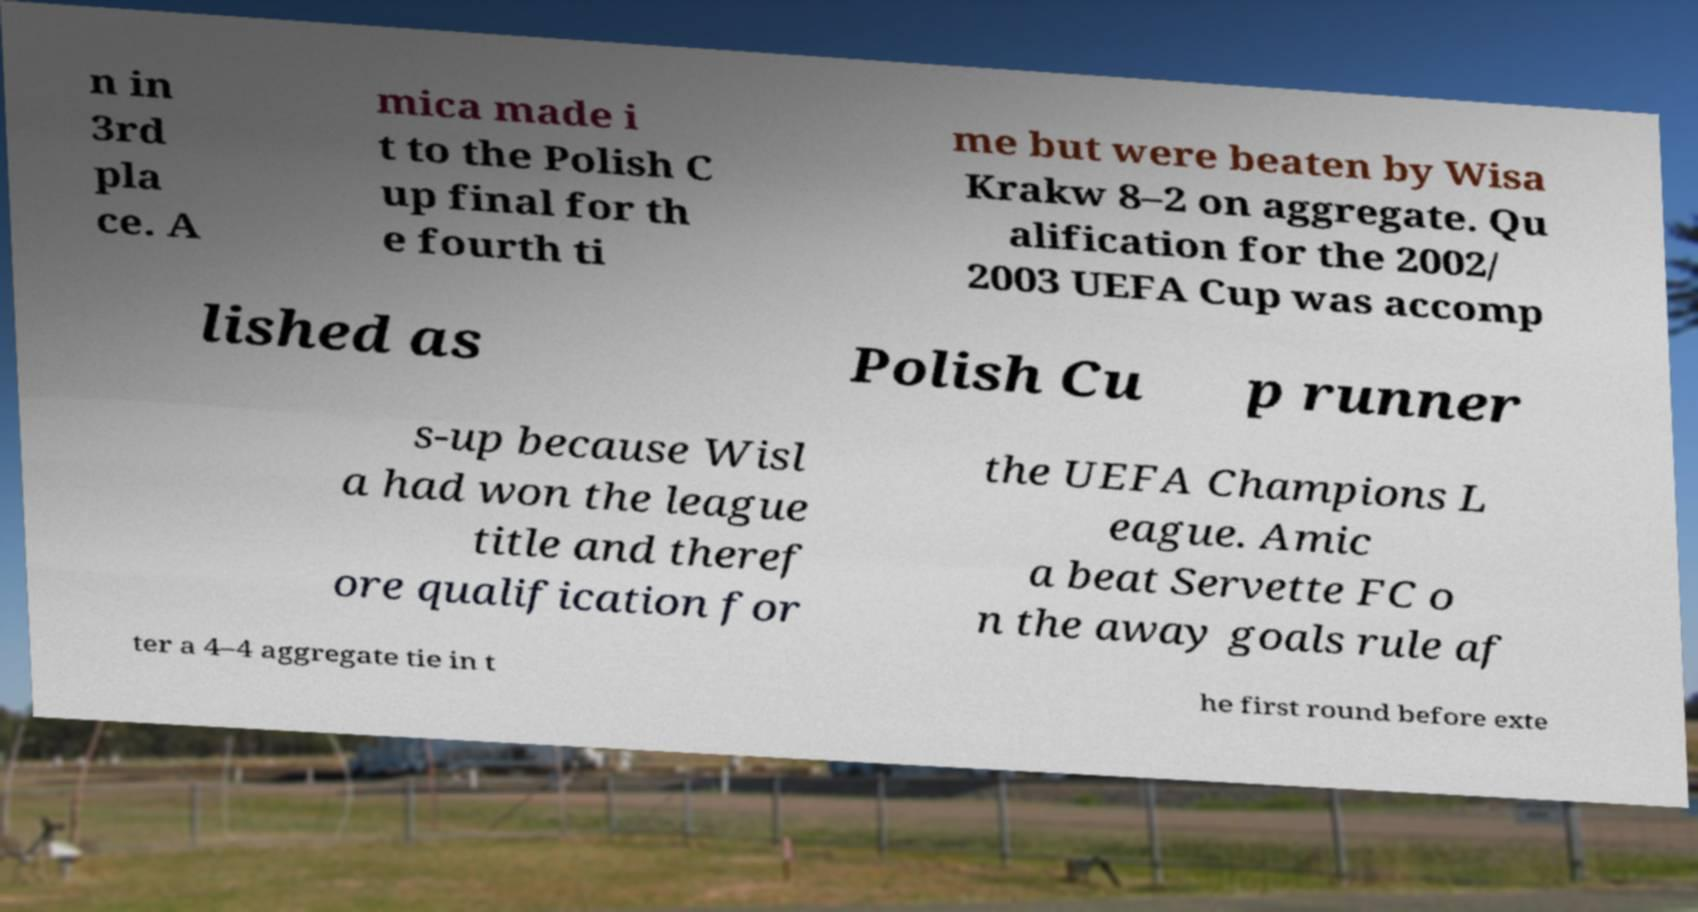Could you extract and type out the text from this image? n in 3rd pla ce. A mica made i t to the Polish C up final for th e fourth ti me but were beaten by Wisa Krakw 8–2 on aggregate. Qu alification for the 2002/ 2003 UEFA Cup was accomp lished as Polish Cu p runner s-up because Wisl a had won the league title and theref ore qualification for the UEFA Champions L eague. Amic a beat Servette FC o n the away goals rule af ter a 4–4 aggregate tie in t he first round before exte 